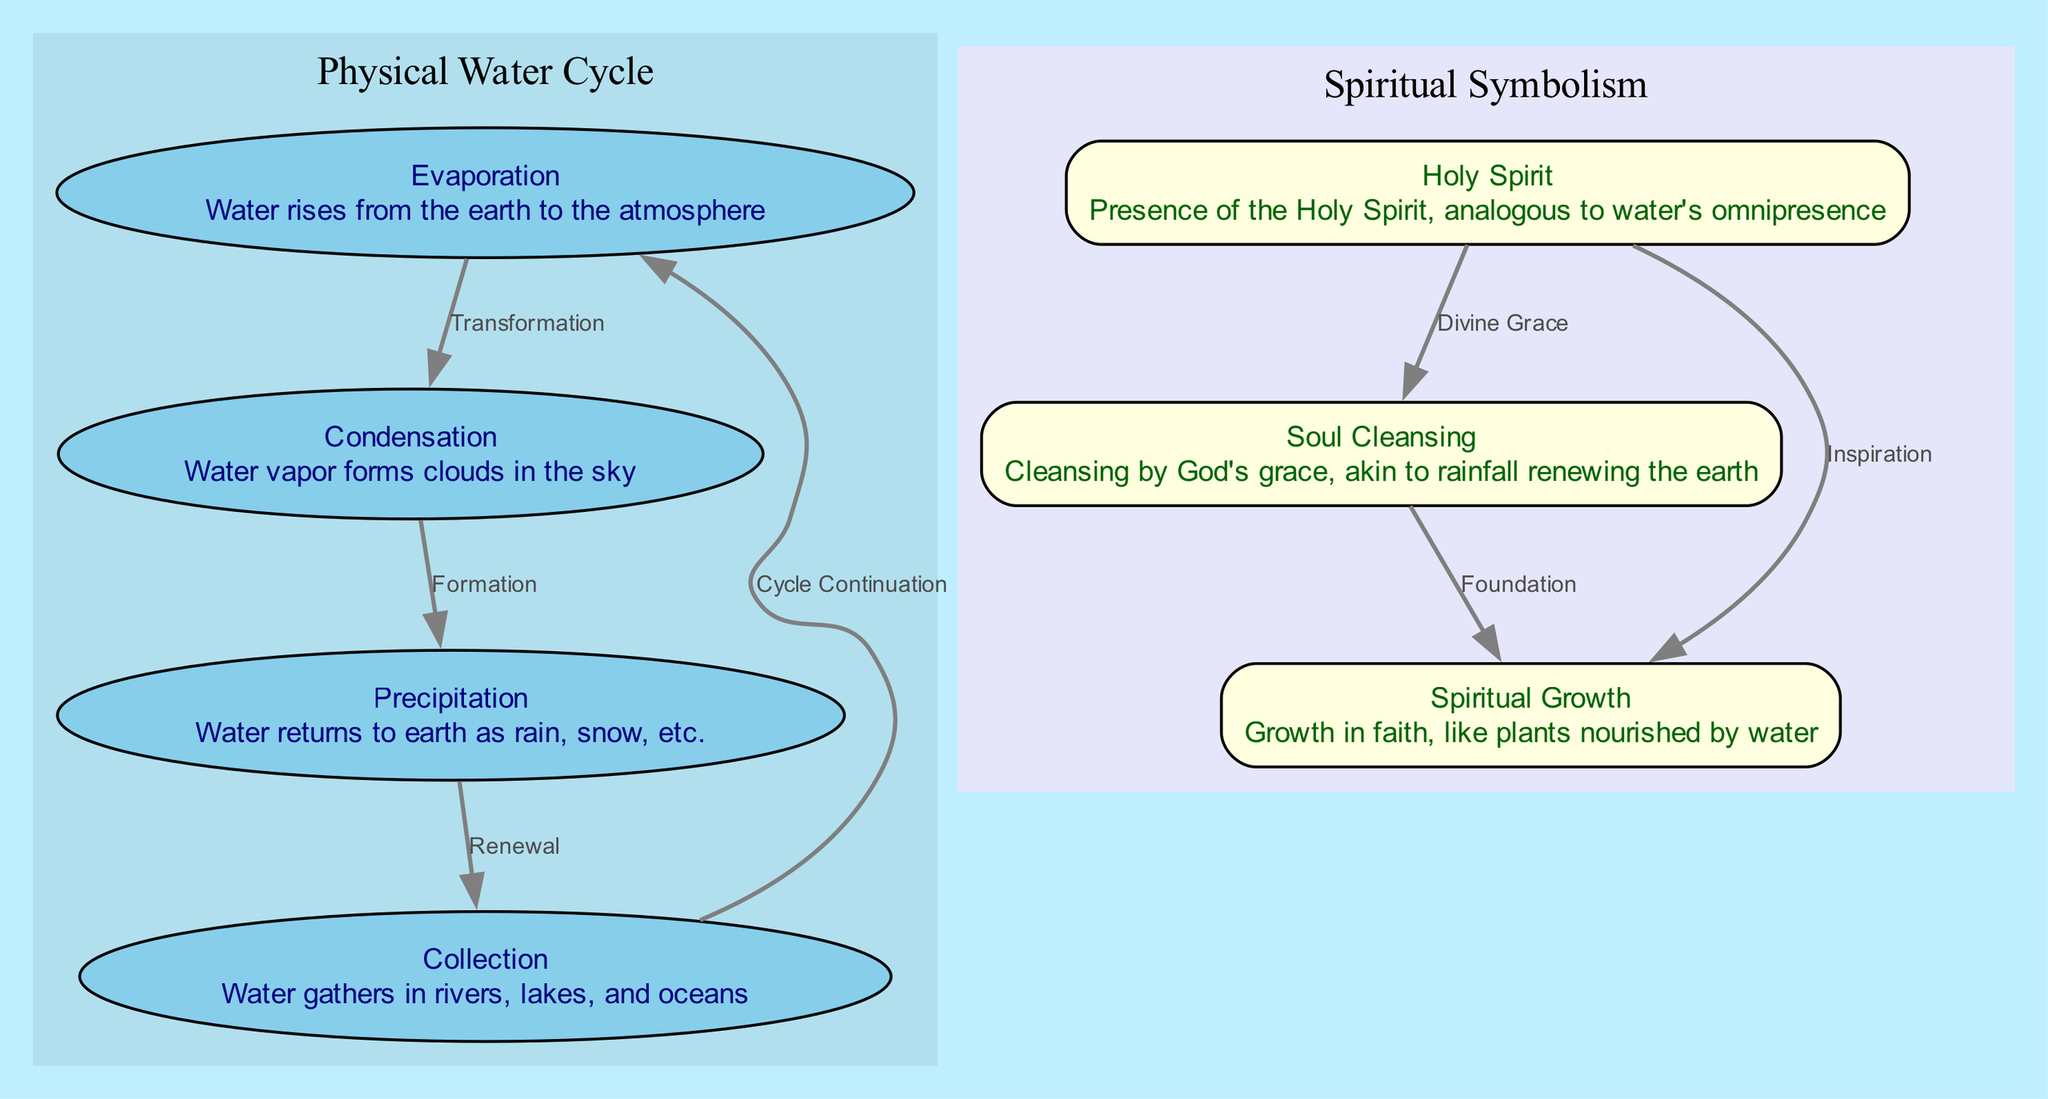What are the four physical nodes in the water cycle? The diagram lists four physical nodes: Evaporation, Condensation, Precipitation, and Collection.
Answer: Evaporation, Condensation, Precipitation, Collection How many spiritual nodes are present in the diagram? Counting the nodes labeled Soul Cleansing, Spiritual Growth, and Holy Spirit results in a total of three spiritual nodes.
Answer: Three What is the relationship labeled between Soul Cleansing and Spiritual Growth? The edge between Soul Cleansing and Spiritual Growth is labeled as Foundation, indicating a foundational relationship.
Answer: Foundation Which spiritual aspect is connected to Divine Grace? The edge from Holy Spirit to Soul Cleansing is labeled Divine Grace, meaning the Holy Spirit is connected to this aspect.
Answer: Soul Cleansing What type of relationship is indicated by the edge from Evaporation to Condensation? The edge indicates a Transformation relationship, which describes the change of state from water vapor to liquid in the diagram.
Answer: Transformation How many edges are present in the diagram? By counting the connections listed in the edges section, there are a total of seven edges illustrated in the diagram.
Answer: Seven What process does Precipitation represent? Precipitation is described as the process where water returns to earth as rain, snow, etc., making it an integral part of the cycle.
Answer: Returns to earth What is the overall function of the Holy Spirit as per the diagram? The Holy Spirit is depicted as having roles analogous to water's omnipresence, represented by its connections to both Soul Cleansing and Spiritual Growth.
Answer: Omnipresence What is the connection type between Collection and Evaporation? The diagram indicates the connection type as Cycle Continuation, which suggests the ongoing flow of the water cycle.
Answer: Cycle Continuation 